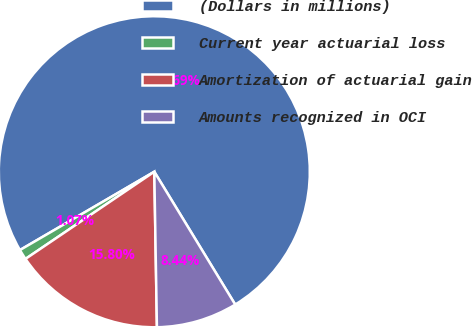Convert chart. <chart><loc_0><loc_0><loc_500><loc_500><pie_chart><fcel>(Dollars in millions)<fcel>Current year actuarial loss<fcel>Amortization of actuarial gain<fcel>Amounts recognized in OCI<nl><fcel>74.69%<fcel>1.07%<fcel>15.8%<fcel>8.44%<nl></chart> 